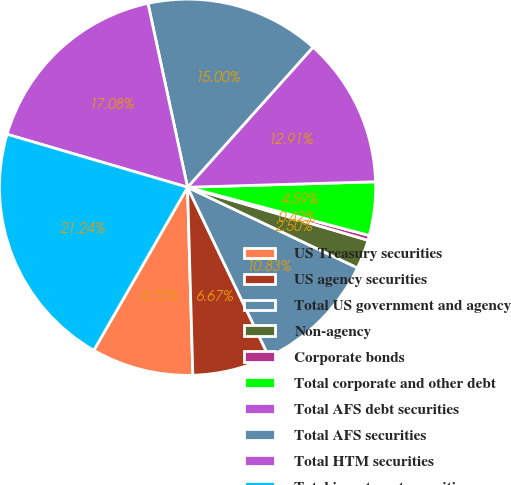Convert chart to OTSL. <chart><loc_0><loc_0><loc_500><loc_500><pie_chart><fcel>US Treasury securities<fcel>US agency securities<fcel>Total US government and agency<fcel>Non-agency<fcel>Corporate bonds<fcel>Total corporate and other debt<fcel>Total AFS debt securities<fcel>Total AFS securities<fcel>Total HTM securities<fcel>Total investment securities<nl><fcel>8.75%<fcel>6.67%<fcel>10.83%<fcel>2.5%<fcel>0.42%<fcel>4.59%<fcel>12.91%<fcel>15.0%<fcel>17.08%<fcel>21.24%<nl></chart> 